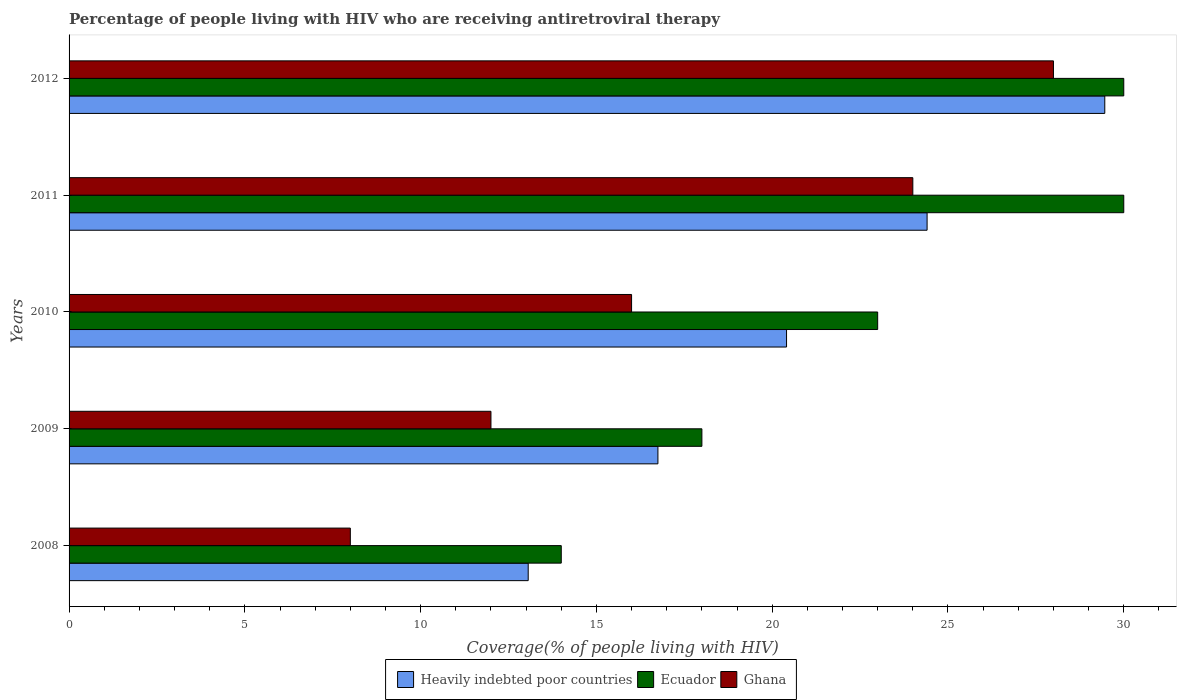How many different coloured bars are there?
Keep it short and to the point. 3. Are the number of bars on each tick of the Y-axis equal?
Your response must be concise. Yes. How many bars are there on the 1st tick from the top?
Provide a succinct answer. 3. How many bars are there on the 3rd tick from the bottom?
Offer a terse response. 3. What is the label of the 2nd group of bars from the top?
Your answer should be compact. 2011. What is the percentage of the HIV infected people who are receiving antiretroviral therapy in Ecuador in 2012?
Offer a terse response. 30. Across all years, what is the maximum percentage of the HIV infected people who are receiving antiretroviral therapy in Ecuador?
Your answer should be very brief. 30. Across all years, what is the minimum percentage of the HIV infected people who are receiving antiretroviral therapy in Heavily indebted poor countries?
Give a very brief answer. 13.06. In which year was the percentage of the HIV infected people who are receiving antiretroviral therapy in Ghana minimum?
Keep it short and to the point. 2008. What is the total percentage of the HIV infected people who are receiving antiretroviral therapy in Ecuador in the graph?
Ensure brevity in your answer.  115. What is the difference between the percentage of the HIV infected people who are receiving antiretroviral therapy in Ecuador in 2008 and that in 2012?
Offer a terse response. -16. What is the difference between the percentage of the HIV infected people who are receiving antiretroviral therapy in Ecuador in 2009 and the percentage of the HIV infected people who are receiving antiretroviral therapy in Heavily indebted poor countries in 2011?
Offer a very short reply. -6.41. What is the average percentage of the HIV infected people who are receiving antiretroviral therapy in Heavily indebted poor countries per year?
Keep it short and to the point. 20.82. In the year 2010, what is the difference between the percentage of the HIV infected people who are receiving antiretroviral therapy in Heavily indebted poor countries and percentage of the HIV infected people who are receiving antiretroviral therapy in Ghana?
Make the answer very short. 4.41. In how many years, is the percentage of the HIV infected people who are receiving antiretroviral therapy in Heavily indebted poor countries greater than 1 %?
Offer a terse response. 5. Is the percentage of the HIV infected people who are receiving antiretroviral therapy in Ecuador in 2009 less than that in 2010?
Make the answer very short. Yes. Is the difference between the percentage of the HIV infected people who are receiving antiretroviral therapy in Heavily indebted poor countries in 2008 and 2012 greater than the difference between the percentage of the HIV infected people who are receiving antiretroviral therapy in Ghana in 2008 and 2012?
Ensure brevity in your answer.  Yes. What is the difference between the highest and the lowest percentage of the HIV infected people who are receiving antiretroviral therapy in Heavily indebted poor countries?
Ensure brevity in your answer.  16.4. Is the sum of the percentage of the HIV infected people who are receiving antiretroviral therapy in Ecuador in 2011 and 2012 greater than the maximum percentage of the HIV infected people who are receiving antiretroviral therapy in Heavily indebted poor countries across all years?
Keep it short and to the point. Yes. What does the 1st bar from the bottom in 2008 represents?
Provide a succinct answer. Heavily indebted poor countries. Is it the case that in every year, the sum of the percentage of the HIV infected people who are receiving antiretroviral therapy in Ecuador and percentage of the HIV infected people who are receiving antiretroviral therapy in Heavily indebted poor countries is greater than the percentage of the HIV infected people who are receiving antiretroviral therapy in Ghana?
Give a very brief answer. Yes. How many bars are there?
Make the answer very short. 15. Are all the bars in the graph horizontal?
Offer a terse response. Yes. How many years are there in the graph?
Ensure brevity in your answer.  5. Does the graph contain any zero values?
Give a very brief answer. No. Where does the legend appear in the graph?
Make the answer very short. Bottom center. How many legend labels are there?
Your answer should be very brief. 3. What is the title of the graph?
Provide a succinct answer. Percentage of people living with HIV who are receiving antiretroviral therapy. What is the label or title of the X-axis?
Your response must be concise. Coverage(% of people living with HIV). What is the Coverage(% of people living with HIV) in Heavily indebted poor countries in 2008?
Give a very brief answer. 13.06. What is the Coverage(% of people living with HIV) of Ghana in 2008?
Your response must be concise. 8. What is the Coverage(% of people living with HIV) of Heavily indebted poor countries in 2009?
Provide a short and direct response. 16.75. What is the Coverage(% of people living with HIV) in Ecuador in 2009?
Ensure brevity in your answer.  18. What is the Coverage(% of people living with HIV) of Heavily indebted poor countries in 2010?
Provide a short and direct response. 20.41. What is the Coverage(% of people living with HIV) in Ghana in 2010?
Give a very brief answer. 16. What is the Coverage(% of people living with HIV) in Heavily indebted poor countries in 2011?
Offer a terse response. 24.41. What is the Coverage(% of people living with HIV) in Ghana in 2011?
Your response must be concise. 24. What is the Coverage(% of people living with HIV) of Heavily indebted poor countries in 2012?
Make the answer very short. 29.46. Across all years, what is the maximum Coverage(% of people living with HIV) of Heavily indebted poor countries?
Your answer should be compact. 29.46. Across all years, what is the maximum Coverage(% of people living with HIV) of Ecuador?
Your response must be concise. 30. Across all years, what is the minimum Coverage(% of people living with HIV) in Heavily indebted poor countries?
Offer a very short reply. 13.06. Across all years, what is the minimum Coverage(% of people living with HIV) of Ecuador?
Keep it short and to the point. 14. Across all years, what is the minimum Coverage(% of people living with HIV) in Ghana?
Make the answer very short. 8. What is the total Coverage(% of people living with HIV) in Heavily indebted poor countries in the graph?
Your answer should be compact. 104.08. What is the total Coverage(% of people living with HIV) in Ecuador in the graph?
Ensure brevity in your answer.  115. What is the total Coverage(% of people living with HIV) in Ghana in the graph?
Offer a very short reply. 88. What is the difference between the Coverage(% of people living with HIV) in Heavily indebted poor countries in 2008 and that in 2009?
Offer a terse response. -3.69. What is the difference between the Coverage(% of people living with HIV) of Ghana in 2008 and that in 2009?
Your answer should be very brief. -4. What is the difference between the Coverage(% of people living with HIV) in Heavily indebted poor countries in 2008 and that in 2010?
Keep it short and to the point. -7.35. What is the difference between the Coverage(% of people living with HIV) of Heavily indebted poor countries in 2008 and that in 2011?
Your answer should be compact. -11.35. What is the difference between the Coverage(% of people living with HIV) in Heavily indebted poor countries in 2008 and that in 2012?
Your answer should be very brief. -16.4. What is the difference between the Coverage(% of people living with HIV) of Ecuador in 2008 and that in 2012?
Make the answer very short. -16. What is the difference between the Coverage(% of people living with HIV) in Ghana in 2008 and that in 2012?
Give a very brief answer. -20. What is the difference between the Coverage(% of people living with HIV) of Heavily indebted poor countries in 2009 and that in 2010?
Offer a terse response. -3.66. What is the difference between the Coverage(% of people living with HIV) in Ecuador in 2009 and that in 2010?
Ensure brevity in your answer.  -5. What is the difference between the Coverage(% of people living with HIV) of Ghana in 2009 and that in 2010?
Make the answer very short. -4. What is the difference between the Coverage(% of people living with HIV) in Heavily indebted poor countries in 2009 and that in 2011?
Your response must be concise. -7.66. What is the difference between the Coverage(% of people living with HIV) of Ecuador in 2009 and that in 2011?
Keep it short and to the point. -12. What is the difference between the Coverage(% of people living with HIV) of Heavily indebted poor countries in 2009 and that in 2012?
Offer a very short reply. -12.71. What is the difference between the Coverage(% of people living with HIV) in Ghana in 2009 and that in 2012?
Make the answer very short. -16. What is the difference between the Coverage(% of people living with HIV) of Heavily indebted poor countries in 2010 and that in 2011?
Provide a short and direct response. -4. What is the difference between the Coverage(% of people living with HIV) of Heavily indebted poor countries in 2010 and that in 2012?
Ensure brevity in your answer.  -9.05. What is the difference between the Coverage(% of people living with HIV) in Ecuador in 2010 and that in 2012?
Your response must be concise. -7. What is the difference between the Coverage(% of people living with HIV) of Ghana in 2010 and that in 2012?
Provide a short and direct response. -12. What is the difference between the Coverage(% of people living with HIV) of Heavily indebted poor countries in 2011 and that in 2012?
Give a very brief answer. -5.05. What is the difference between the Coverage(% of people living with HIV) in Heavily indebted poor countries in 2008 and the Coverage(% of people living with HIV) in Ecuador in 2009?
Your response must be concise. -4.94. What is the difference between the Coverage(% of people living with HIV) in Heavily indebted poor countries in 2008 and the Coverage(% of people living with HIV) in Ghana in 2009?
Ensure brevity in your answer.  1.06. What is the difference between the Coverage(% of people living with HIV) in Heavily indebted poor countries in 2008 and the Coverage(% of people living with HIV) in Ecuador in 2010?
Offer a terse response. -9.94. What is the difference between the Coverage(% of people living with HIV) in Heavily indebted poor countries in 2008 and the Coverage(% of people living with HIV) in Ghana in 2010?
Offer a terse response. -2.94. What is the difference between the Coverage(% of people living with HIV) in Heavily indebted poor countries in 2008 and the Coverage(% of people living with HIV) in Ecuador in 2011?
Make the answer very short. -16.94. What is the difference between the Coverage(% of people living with HIV) of Heavily indebted poor countries in 2008 and the Coverage(% of people living with HIV) of Ghana in 2011?
Provide a short and direct response. -10.94. What is the difference between the Coverage(% of people living with HIV) of Ecuador in 2008 and the Coverage(% of people living with HIV) of Ghana in 2011?
Ensure brevity in your answer.  -10. What is the difference between the Coverage(% of people living with HIV) in Heavily indebted poor countries in 2008 and the Coverage(% of people living with HIV) in Ecuador in 2012?
Make the answer very short. -16.94. What is the difference between the Coverage(% of people living with HIV) of Heavily indebted poor countries in 2008 and the Coverage(% of people living with HIV) of Ghana in 2012?
Provide a short and direct response. -14.94. What is the difference between the Coverage(% of people living with HIV) in Ecuador in 2008 and the Coverage(% of people living with HIV) in Ghana in 2012?
Your answer should be compact. -14. What is the difference between the Coverage(% of people living with HIV) of Heavily indebted poor countries in 2009 and the Coverage(% of people living with HIV) of Ecuador in 2010?
Offer a terse response. -6.25. What is the difference between the Coverage(% of people living with HIV) in Heavily indebted poor countries in 2009 and the Coverage(% of people living with HIV) in Ghana in 2010?
Offer a terse response. 0.75. What is the difference between the Coverage(% of people living with HIV) of Heavily indebted poor countries in 2009 and the Coverage(% of people living with HIV) of Ecuador in 2011?
Provide a short and direct response. -13.25. What is the difference between the Coverage(% of people living with HIV) in Heavily indebted poor countries in 2009 and the Coverage(% of people living with HIV) in Ghana in 2011?
Your answer should be very brief. -7.25. What is the difference between the Coverage(% of people living with HIV) in Ecuador in 2009 and the Coverage(% of people living with HIV) in Ghana in 2011?
Provide a succinct answer. -6. What is the difference between the Coverage(% of people living with HIV) in Heavily indebted poor countries in 2009 and the Coverage(% of people living with HIV) in Ecuador in 2012?
Your answer should be compact. -13.25. What is the difference between the Coverage(% of people living with HIV) in Heavily indebted poor countries in 2009 and the Coverage(% of people living with HIV) in Ghana in 2012?
Provide a succinct answer. -11.25. What is the difference between the Coverage(% of people living with HIV) in Ecuador in 2009 and the Coverage(% of people living with HIV) in Ghana in 2012?
Provide a succinct answer. -10. What is the difference between the Coverage(% of people living with HIV) in Heavily indebted poor countries in 2010 and the Coverage(% of people living with HIV) in Ecuador in 2011?
Provide a succinct answer. -9.59. What is the difference between the Coverage(% of people living with HIV) in Heavily indebted poor countries in 2010 and the Coverage(% of people living with HIV) in Ghana in 2011?
Offer a very short reply. -3.59. What is the difference between the Coverage(% of people living with HIV) of Heavily indebted poor countries in 2010 and the Coverage(% of people living with HIV) of Ecuador in 2012?
Your response must be concise. -9.59. What is the difference between the Coverage(% of people living with HIV) of Heavily indebted poor countries in 2010 and the Coverage(% of people living with HIV) of Ghana in 2012?
Your response must be concise. -7.59. What is the difference between the Coverage(% of people living with HIV) in Heavily indebted poor countries in 2011 and the Coverage(% of people living with HIV) in Ecuador in 2012?
Your response must be concise. -5.59. What is the difference between the Coverage(% of people living with HIV) in Heavily indebted poor countries in 2011 and the Coverage(% of people living with HIV) in Ghana in 2012?
Your response must be concise. -3.59. What is the average Coverage(% of people living with HIV) of Heavily indebted poor countries per year?
Your answer should be compact. 20.82. What is the average Coverage(% of people living with HIV) in Ghana per year?
Provide a succinct answer. 17.6. In the year 2008, what is the difference between the Coverage(% of people living with HIV) in Heavily indebted poor countries and Coverage(% of people living with HIV) in Ecuador?
Your response must be concise. -0.94. In the year 2008, what is the difference between the Coverage(% of people living with HIV) of Heavily indebted poor countries and Coverage(% of people living with HIV) of Ghana?
Offer a very short reply. 5.06. In the year 2009, what is the difference between the Coverage(% of people living with HIV) of Heavily indebted poor countries and Coverage(% of people living with HIV) of Ecuador?
Provide a succinct answer. -1.25. In the year 2009, what is the difference between the Coverage(% of people living with HIV) of Heavily indebted poor countries and Coverage(% of people living with HIV) of Ghana?
Make the answer very short. 4.75. In the year 2009, what is the difference between the Coverage(% of people living with HIV) in Ecuador and Coverage(% of people living with HIV) in Ghana?
Provide a succinct answer. 6. In the year 2010, what is the difference between the Coverage(% of people living with HIV) of Heavily indebted poor countries and Coverage(% of people living with HIV) of Ecuador?
Your response must be concise. -2.59. In the year 2010, what is the difference between the Coverage(% of people living with HIV) of Heavily indebted poor countries and Coverage(% of people living with HIV) of Ghana?
Ensure brevity in your answer.  4.41. In the year 2010, what is the difference between the Coverage(% of people living with HIV) of Ecuador and Coverage(% of people living with HIV) of Ghana?
Offer a very short reply. 7. In the year 2011, what is the difference between the Coverage(% of people living with HIV) of Heavily indebted poor countries and Coverage(% of people living with HIV) of Ecuador?
Provide a short and direct response. -5.59. In the year 2011, what is the difference between the Coverage(% of people living with HIV) in Heavily indebted poor countries and Coverage(% of people living with HIV) in Ghana?
Keep it short and to the point. 0.41. In the year 2011, what is the difference between the Coverage(% of people living with HIV) in Ecuador and Coverage(% of people living with HIV) in Ghana?
Ensure brevity in your answer.  6. In the year 2012, what is the difference between the Coverage(% of people living with HIV) in Heavily indebted poor countries and Coverage(% of people living with HIV) in Ecuador?
Your answer should be very brief. -0.54. In the year 2012, what is the difference between the Coverage(% of people living with HIV) of Heavily indebted poor countries and Coverage(% of people living with HIV) of Ghana?
Ensure brevity in your answer.  1.46. What is the ratio of the Coverage(% of people living with HIV) of Heavily indebted poor countries in 2008 to that in 2009?
Your answer should be very brief. 0.78. What is the ratio of the Coverage(% of people living with HIV) of Ghana in 2008 to that in 2009?
Provide a short and direct response. 0.67. What is the ratio of the Coverage(% of people living with HIV) of Heavily indebted poor countries in 2008 to that in 2010?
Offer a terse response. 0.64. What is the ratio of the Coverage(% of people living with HIV) of Ecuador in 2008 to that in 2010?
Offer a terse response. 0.61. What is the ratio of the Coverage(% of people living with HIV) in Heavily indebted poor countries in 2008 to that in 2011?
Make the answer very short. 0.54. What is the ratio of the Coverage(% of people living with HIV) in Ecuador in 2008 to that in 2011?
Provide a short and direct response. 0.47. What is the ratio of the Coverage(% of people living with HIV) of Heavily indebted poor countries in 2008 to that in 2012?
Provide a succinct answer. 0.44. What is the ratio of the Coverage(% of people living with HIV) in Ecuador in 2008 to that in 2012?
Keep it short and to the point. 0.47. What is the ratio of the Coverage(% of people living with HIV) in Ghana in 2008 to that in 2012?
Your response must be concise. 0.29. What is the ratio of the Coverage(% of people living with HIV) in Heavily indebted poor countries in 2009 to that in 2010?
Keep it short and to the point. 0.82. What is the ratio of the Coverage(% of people living with HIV) in Ecuador in 2009 to that in 2010?
Your answer should be compact. 0.78. What is the ratio of the Coverage(% of people living with HIV) in Ghana in 2009 to that in 2010?
Offer a very short reply. 0.75. What is the ratio of the Coverage(% of people living with HIV) of Heavily indebted poor countries in 2009 to that in 2011?
Your answer should be compact. 0.69. What is the ratio of the Coverage(% of people living with HIV) of Heavily indebted poor countries in 2009 to that in 2012?
Your answer should be very brief. 0.57. What is the ratio of the Coverage(% of people living with HIV) in Ghana in 2009 to that in 2012?
Your answer should be very brief. 0.43. What is the ratio of the Coverage(% of people living with HIV) of Heavily indebted poor countries in 2010 to that in 2011?
Your response must be concise. 0.84. What is the ratio of the Coverage(% of people living with HIV) of Ecuador in 2010 to that in 2011?
Give a very brief answer. 0.77. What is the ratio of the Coverage(% of people living with HIV) of Heavily indebted poor countries in 2010 to that in 2012?
Offer a terse response. 0.69. What is the ratio of the Coverage(% of people living with HIV) of Ecuador in 2010 to that in 2012?
Offer a terse response. 0.77. What is the ratio of the Coverage(% of people living with HIV) of Heavily indebted poor countries in 2011 to that in 2012?
Offer a terse response. 0.83. What is the difference between the highest and the second highest Coverage(% of people living with HIV) in Heavily indebted poor countries?
Your answer should be very brief. 5.05. What is the difference between the highest and the second highest Coverage(% of people living with HIV) of Ghana?
Make the answer very short. 4. What is the difference between the highest and the lowest Coverage(% of people living with HIV) of Heavily indebted poor countries?
Offer a terse response. 16.4. What is the difference between the highest and the lowest Coverage(% of people living with HIV) in Ecuador?
Your response must be concise. 16. 